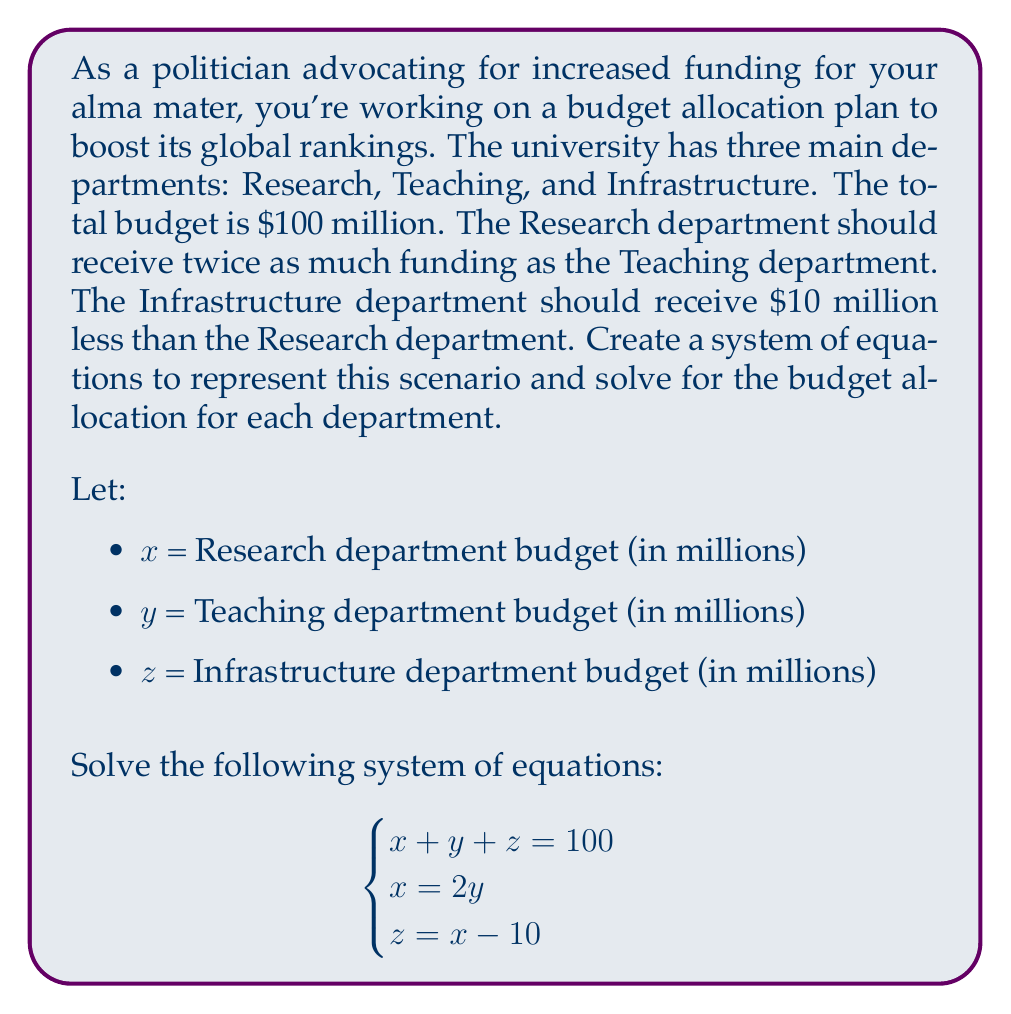Can you solve this math problem? Let's solve this system of equations step by step:

1) From the second equation, we know that $x = 2y$. We can substitute this into the other equations.

2) Substituting $x = 2y$ into the third equation:
   $z = x - 10$
   $z = 2y - 10$

3) Now we can substitute both of these into the first equation:
   $x + y + z = 100$
   $2y + y + (2y - 10) = 100$

4) Simplify:
   $5y - 10 = 100$

5) Solve for $y$:
   $5y = 110$
   $y = 22$

6) Now that we know $y$, we can find $x$ and $z$:
   $x = 2y = 2(22) = 44$
   $z = x - 10 = 44 - 10 = 34$

7) Let's verify that these values satisfy all equations:
   $x + y + z = 44 + 22 + 34 = 100$ ✓
   $x = 2y$ : $44 = 2(22)$ ✓
   $z = x - 10$ : $34 = 44 - 10$ ✓

Therefore, the solution is:
Research department (x): $44 million
Teaching department (y): $22 million
Infrastructure department (z): $34 million
Answer: Research department: $44 million
Teaching department: $22 million
Infrastructure department: $34 million 